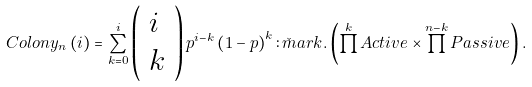Convert formula to latex. <formula><loc_0><loc_0><loc_500><loc_500>C o l o n y _ { n } \left ( i \right ) = \sum _ { k = 0 } ^ { i } \left ( \begin{array} { l } i \\ k \end{array} \right ) p ^ { i - k } \left ( 1 - p \right ) ^ { k } \colon \check { m } a r k . \left ( \prod ^ { k } A c t i v e \times \prod ^ { n - k } P a s s i v e \right ) .</formula> 